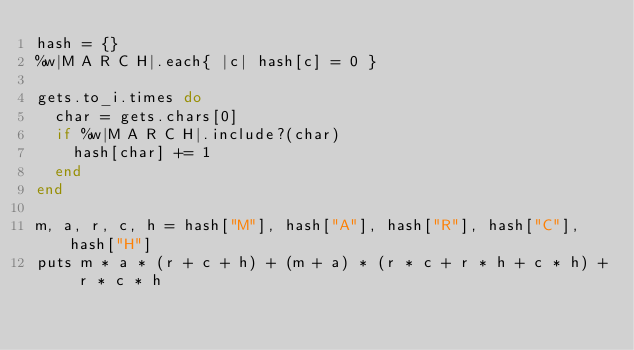Convert code to text. <code><loc_0><loc_0><loc_500><loc_500><_Ruby_>hash = {}
%w|M A R C H|.each{ |c| hash[c] = 0 }

gets.to_i.times do
  char = gets.chars[0]
  if %w|M A R C H|.include?(char)
    hash[char] += 1
  end
end

m, a, r, c, h = hash["M"], hash["A"], hash["R"], hash["C"], hash["H"]
puts m * a * (r + c + h) + (m + a) * (r * c + r * h + c * h) + r * c * h
</code> 